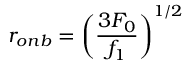<formula> <loc_0><loc_0><loc_500><loc_500>r _ { o n b } = \left ( \frac { 3 F _ { 0 } } { f _ { 1 } } \right ) ^ { 1 / 2 }</formula> 